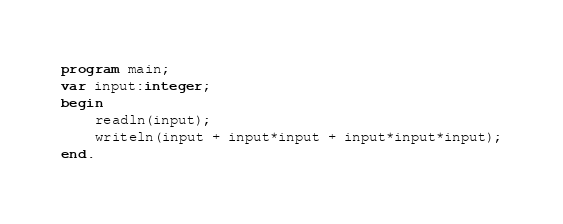Convert code to text. <code><loc_0><loc_0><loc_500><loc_500><_Pascal_>program main;
var input:integer;
begin
	readln(input);
    writeln(input + input*input + input*input*input);
end.</code> 